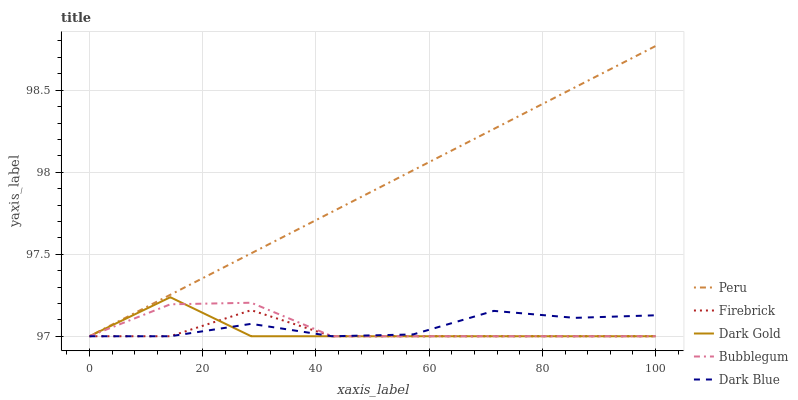Does Firebrick have the minimum area under the curve?
Answer yes or no. Yes. Does Peru have the maximum area under the curve?
Answer yes or no. Yes. Does Bubblegum have the minimum area under the curve?
Answer yes or no. No. Does Bubblegum have the maximum area under the curve?
Answer yes or no. No. Is Peru the smoothest?
Answer yes or no. Yes. Is Dark Gold the roughest?
Answer yes or no. Yes. Is Firebrick the smoothest?
Answer yes or no. No. Is Firebrick the roughest?
Answer yes or no. No. Does Dark Blue have the lowest value?
Answer yes or no. Yes. Does Peru have the highest value?
Answer yes or no. Yes. Does Firebrick have the highest value?
Answer yes or no. No. Does Bubblegum intersect Dark Gold?
Answer yes or no. Yes. Is Bubblegum less than Dark Gold?
Answer yes or no. No. Is Bubblegum greater than Dark Gold?
Answer yes or no. No. 